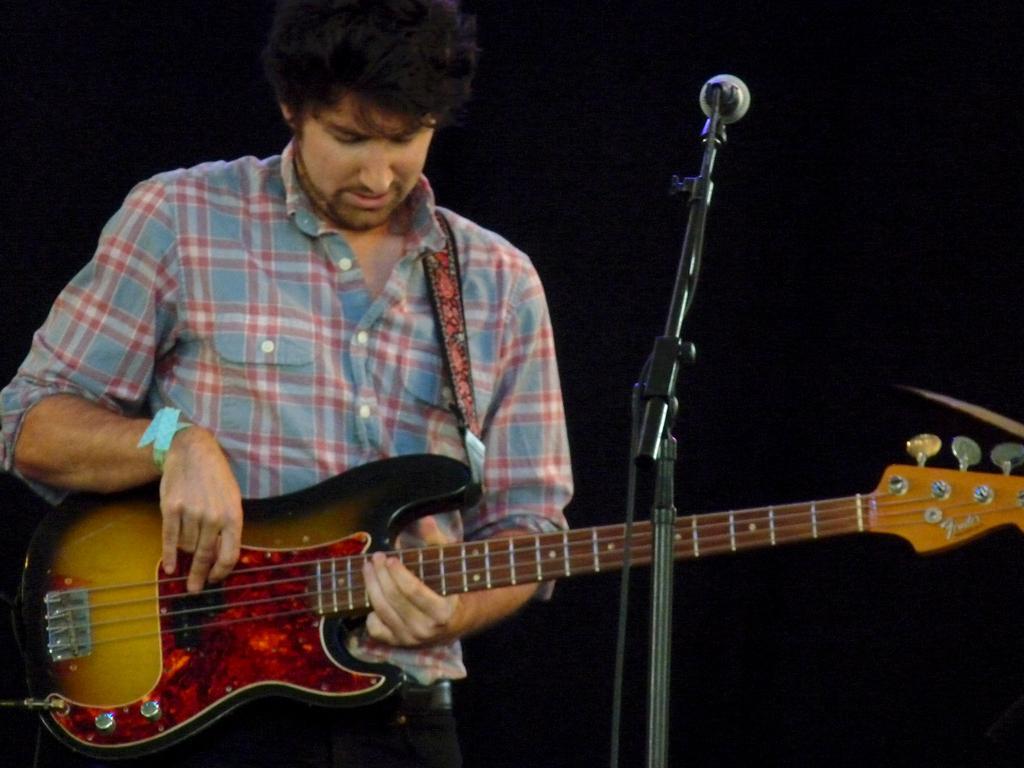What is the man in the image doing? The man is playing a guitar in the image. What object is present in the image that is commonly used for amplifying sound? There is a microphone in the image. What type of friction is being generated by the guitar strings in the image? There is no information about the friction generated by the guitar strings in the image. 